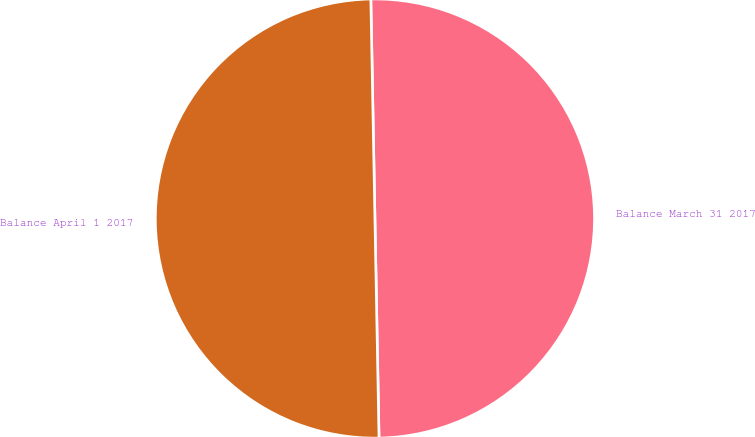<chart> <loc_0><loc_0><loc_500><loc_500><pie_chart><fcel>Balance March 31 2017<fcel>Balance April 1 2017<nl><fcel>50.0%<fcel>50.0%<nl></chart> 